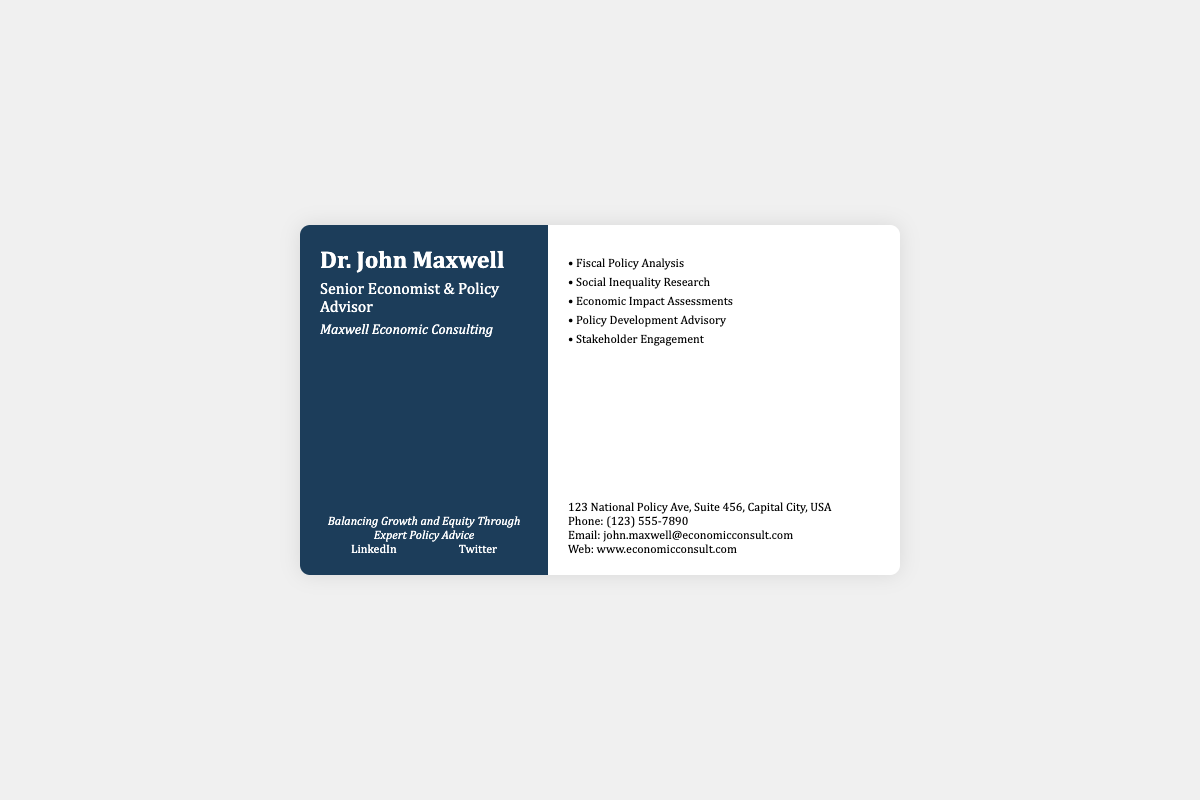What is the name of the consultant? The consultant's name is prominently displayed at the top of the card.
Answer: Dr. John Maxwell What is the title of the consultant? The title under the name indicates the consultant's role.
Answer: Senior Economist & Policy Advisor What is the name of the consulting company? The card includes the name of the organization providing consulting services.
Answer: Maxwell Economic Consulting What is one service offered by the consultant? A list of services provided includes various economic consulting activities; one is highlighted.
Answer: Fiscal Policy Analysis How many services are listed on the card? The services section details multiple offerings and requires counting.
Answer: Five What is the contact phone number? The phone number is part of the contact section for getting in touch with the consultant.
Answer: (123) 555-7890 Where is the office located? The address is specified in the contact details section on the card.
Answer: 123 National Policy Ave, Suite 456, Capital City, USA What tagline is used on the card? The tagline reflects the consultant's business philosophy found below the company name.
Answer: Balancing Growth and Equity Through Expert Policy Advice Which social media platforms are mentioned? Two links for social media platforms provide additional connection options for the consultant.
Answer: LinkedIn and Twitter 